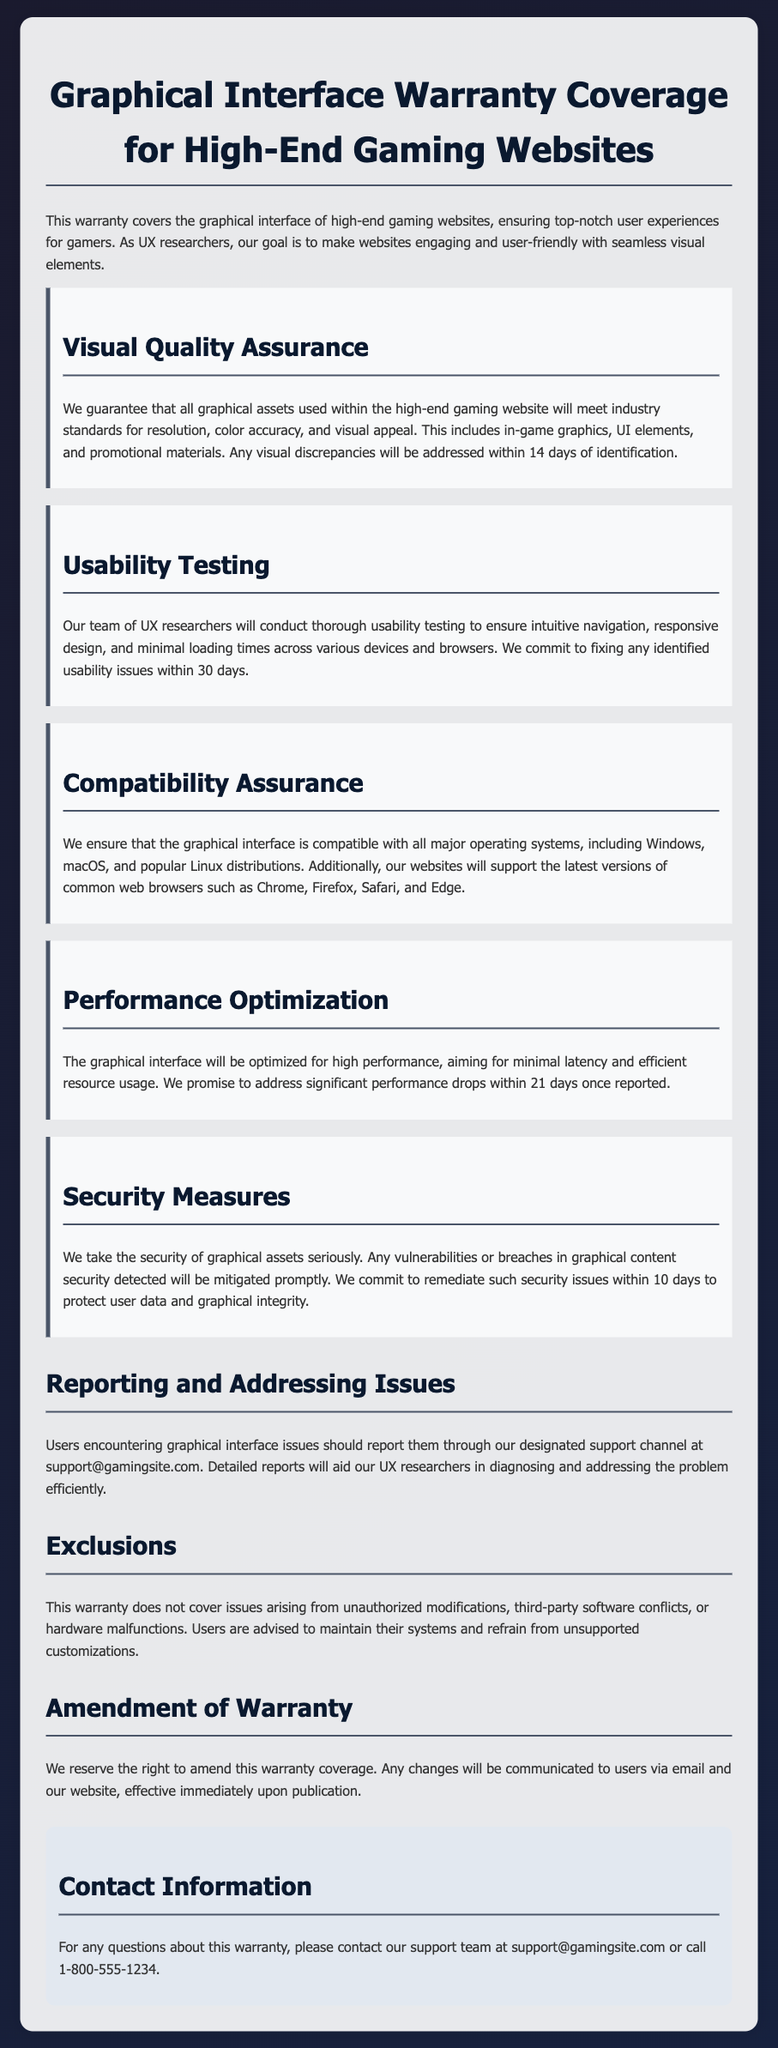What is covered by the warranty? The warranty covers the graphical interface of high-end gaming websites, ensuring top-notch user experiences.
Answer: Graphical interface What is the time frame for addressing visual discrepancies? Visual discrepancies will be addressed within 14 days of identification as stated in the document.
Answer: 14 days Who conducts usability testing? The document states that a team of UX researchers conducts the usability testing.
Answer: UX researchers What does the warranty guarantee regarding compatibility? The warranty ensures that the graphical interface is compatible with all major operating systems.
Answer: Compatibility with all major operating systems How long does the warranty allow for fixing usability issues? It allows for fixing identified usability issues within 30 days.
Answer: 30 days What type of issues are excluded from the warranty? The warranty does not cover issues arising from unauthorized modifications.
Answer: Unauthorized modifications What is the commitment regarding performance optimization? The commitment is to address significant performance drops within 21 days once reported.
Answer: 21 days What email should users use to report issues? Users should report issues through the email support@gamingsite.com as specified.
Answer: support@gamingsite.com What are the security measures mentioned in the warranty? The warranty mentions that any vulnerabilities detected will be mitigated promptly.
Answer: Mitigated promptly 